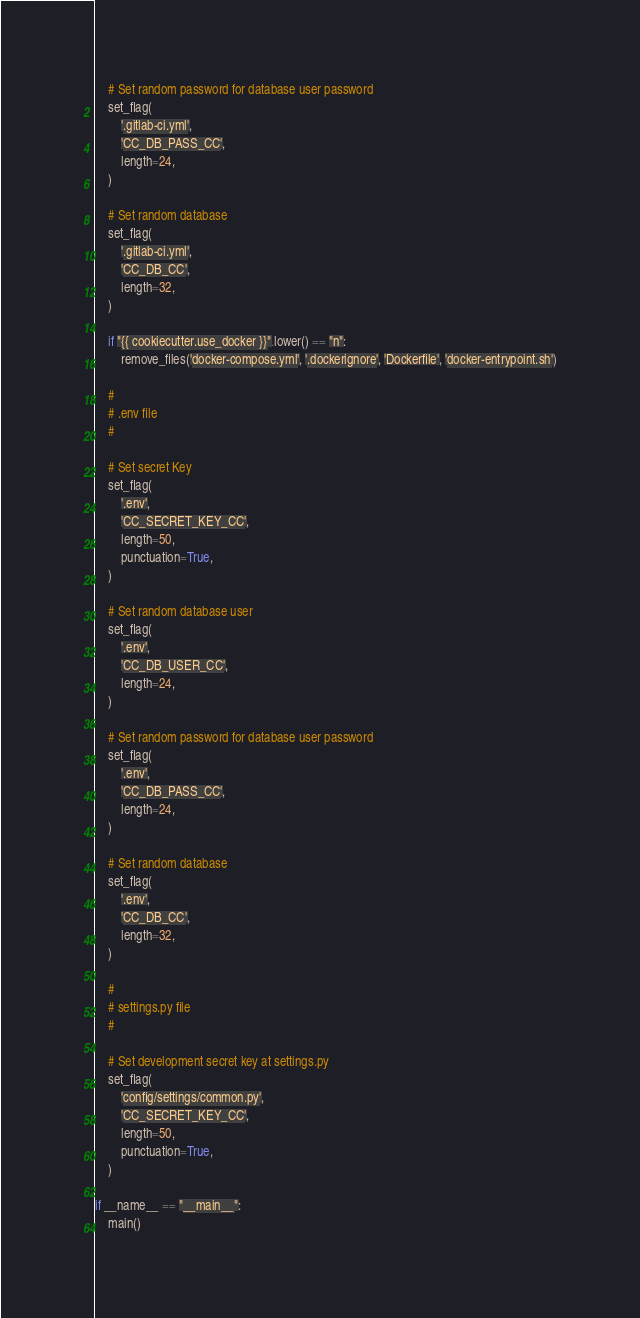<code> <loc_0><loc_0><loc_500><loc_500><_Python_>
    # Set random password for database user password
    set_flag(
        '.gitlab-ci.yml',
        'CC_DB_PASS_CC',
        length=24,
    )

    # Set random database
    set_flag(
        '.gitlab-ci.yml',
        'CC_DB_CC',
        length=32,
    )

    if "{{ cookiecutter.use_docker }}".lower() == "n":
        remove_files('docker-compose.yml', '.dockerignore', 'Dockerfile', 'docker-entrypoint.sh')

    #
    # .env file
    #

    # Set secret Key
    set_flag(
        '.env',
        'CC_SECRET_KEY_CC',
        length=50,
        punctuation=True,
    )

    # Set random database user
    set_flag(
        '.env',
        'CC_DB_USER_CC',
        length=24,
    )

    # Set random password for database user password
    set_flag(
        '.env',
        'CC_DB_PASS_CC',
        length=24,
    )

    # Set random database
    set_flag(
        '.env',
        'CC_DB_CC',
        length=32,
    )

    #
    # settings.py file
    #

    # Set development secret key at settings.py
    set_flag(
        'config/settings/common.py',
        'CC_SECRET_KEY_CC',
        length=50,
        punctuation=True,
    )

if __name__ == "__main__":
    main()
</code> 